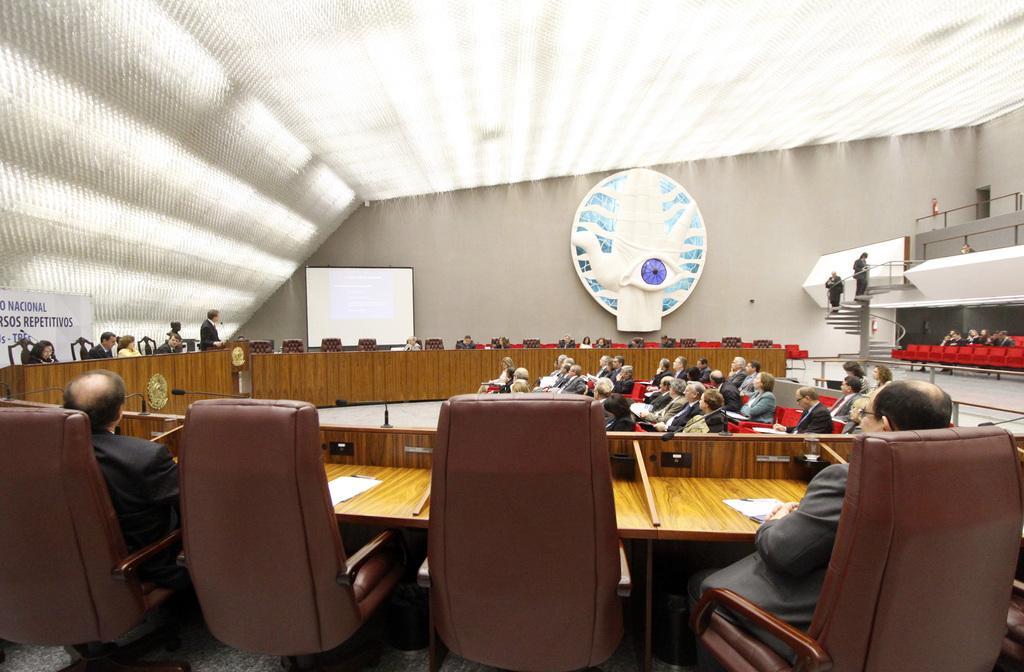In one or two sentences, can you explain what this image depicts? This is a picture of conference room. Here we can see screen. We can see persons on the stairs and all the persons sitting on chairs in front of a table and on the table we can see papers. This is flexi. We can see one man standing near to the screen in front of a mike. This is a logo. 